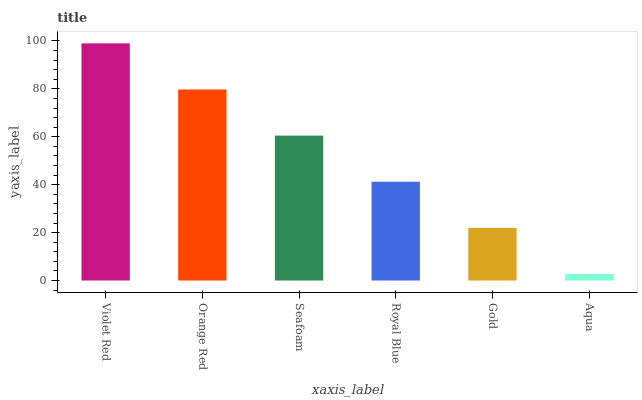Is Aqua the minimum?
Answer yes or no. Yes. Is Violet Red the maximum?
Answer yes or no. Yes. Is Orange Red the minimum?
Answer yes or no. No. Is Orange Red the maximum?
Answer yes or no. No. Is Violet Red greater than Orange Red?
Answer yes or no. Yes. Is Orange Red less than Violet Red?
Answer yes or no. Yes. Is Orange Red greater than Violet Red?
Answer yes or no. No. Is Violet Red less than Orange Red?
Answer yes or no. No. Is Seafoam the high median?
Answer yes or no. Yes. Is Royal Blue the low median?
Answer yes or no. Yes. Is Gold the high median?
Answer yes or no. No. Is Gold the low median?
Answer yes or no. No. 